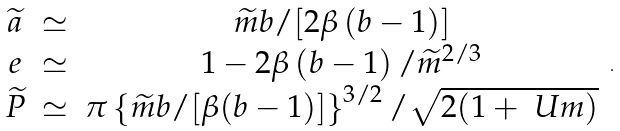Convert formula to latex. <formula><loc_0><loc_0><loc_500><loc_500>\begin{array} { c c c } \widetilde { a } & \simeq & \widetilde { m } b / [ 2 \beta \left ( b - 1 \right ) ] \\ e & \simeq & 1 - 2 \beta \left ( b - 1 \right ) / \widetilde { m } ^ { 2 / 3 } \\ \widetilde { P } & \simeq & \pi \left \{ \widetilde { m } b / [ \beta ( b - 1 ) ] \right \} ^ { 3 / 2 } / \sqrt { 2 ( 1 + \ U m ) } \end{array} \, .</formula> 